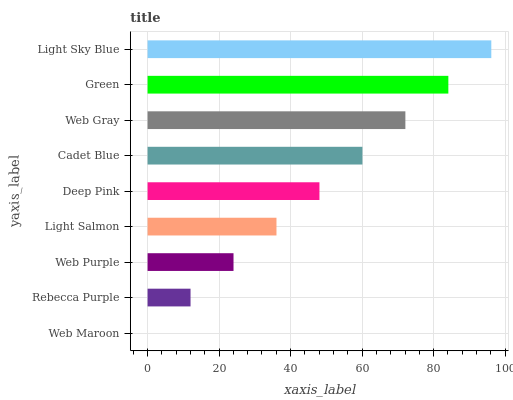Is Web Maroon the minimum?
Answer yes or no. Yes. Is Light Sky Blue the maximum?
Answer yes or no. Yes. Is Rebecca Purple the minimum?
Answer yes or no. No. Is Rebecca Purple the maximum?
Answer yes or no. No. Is Rebecca Purple greater than Web Maroon?
Answer yes or no. Yes. Is Web Maroon less than Rebecca Purple?
Answer yes or no. Yes. Is Web Maroon greater than Rebecca Purple?
Answer yes or no. No. Is Rebecca Purple less than Web Maroon?
Answer yes or no. No. Is Deep Pink the high median?
Answer yes or no. Yes. Is Deep Pink the low median?
Answer yes or no. Yes. Is Cadet Blue the high median?
Answer yes or no. No. Is Web Maroon the low median?
Answer yes or no. No. 